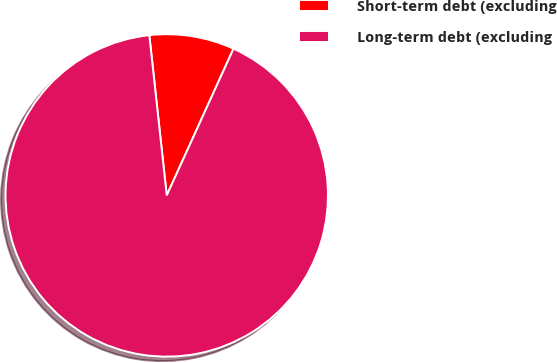<chart> <loc_0><loc_0><loc_500><loc_500><pie_chart><fcel>Short-term debt (excluding<fcel>Long-term debt (excluding<nl><fcel>8.52%<fcel>91.48%<nl></chart> 